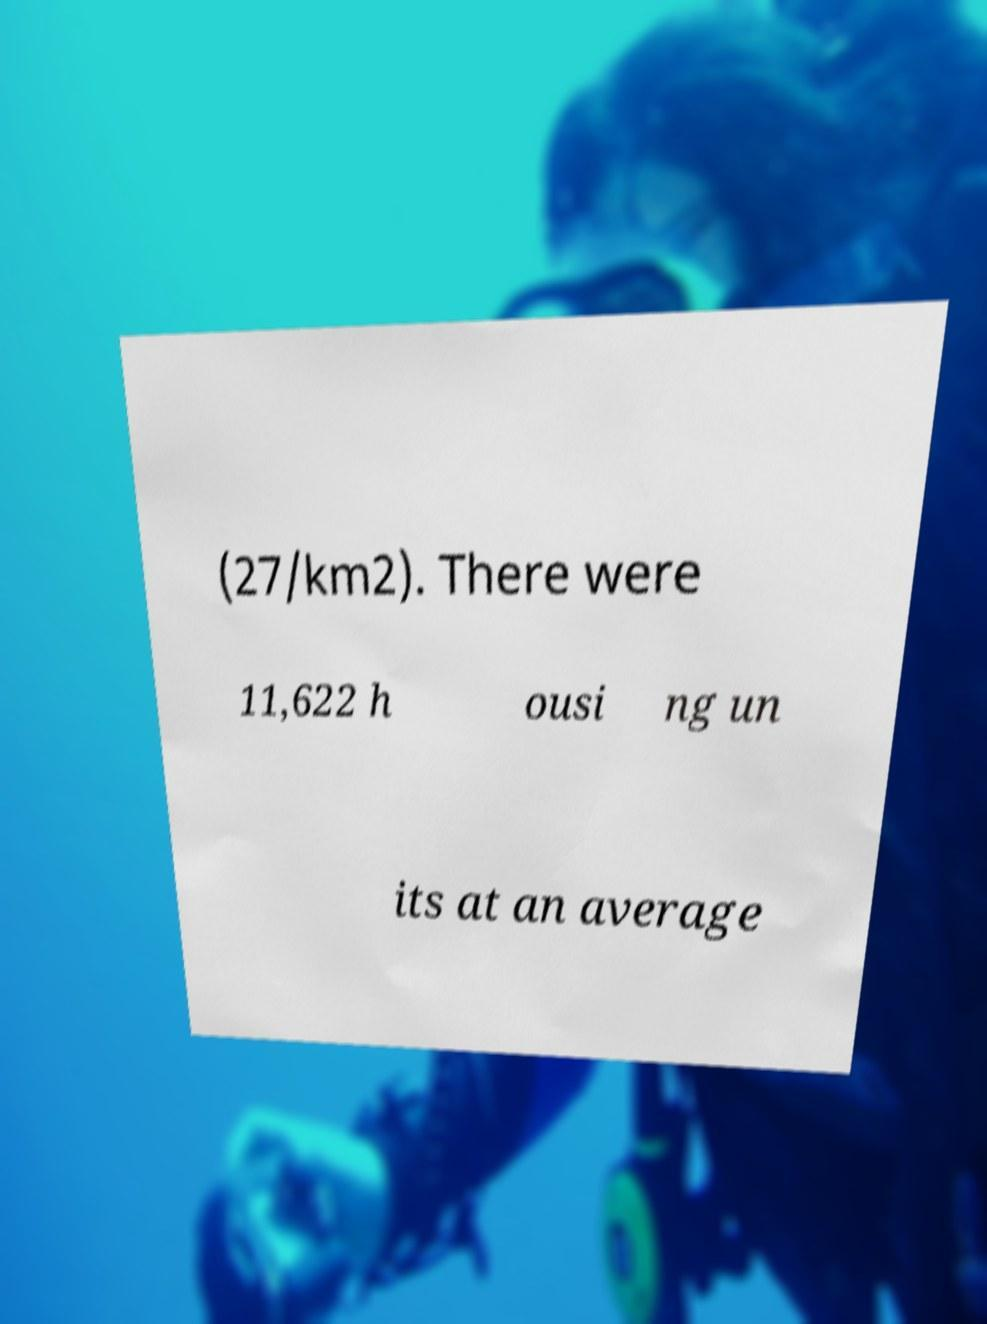What messages or text are displayed in this image? I need them in a readable, typed format. (27/km2). There were 11,622 h ousi ng un its at an average 